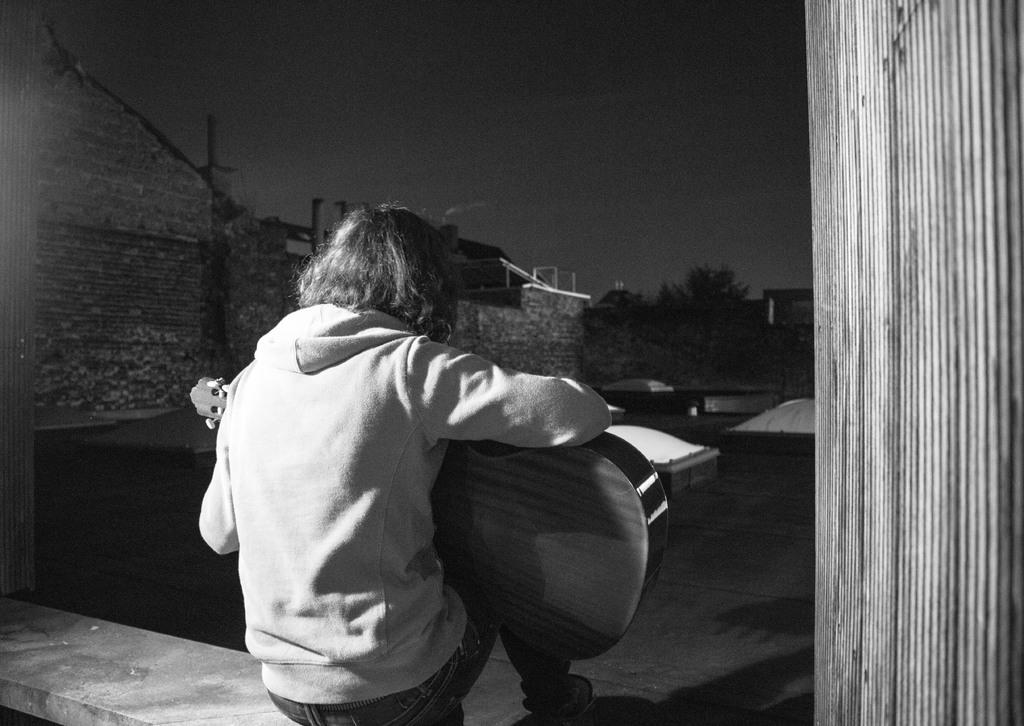What is the color scheme of the image? The image is black and white. What is the person in the image doing? The person is playing a guitar in the image. What can be seen on the left side of the image? There is a brick wall on the left side of the image. What type of vegetation is near the wall in the image? There are trees beside the wall in the image. What type of button can be seen on the person's shirt in the image? There is no button visible on the person's shirt in the image, as the image is black and white and does not show details of clothing. 